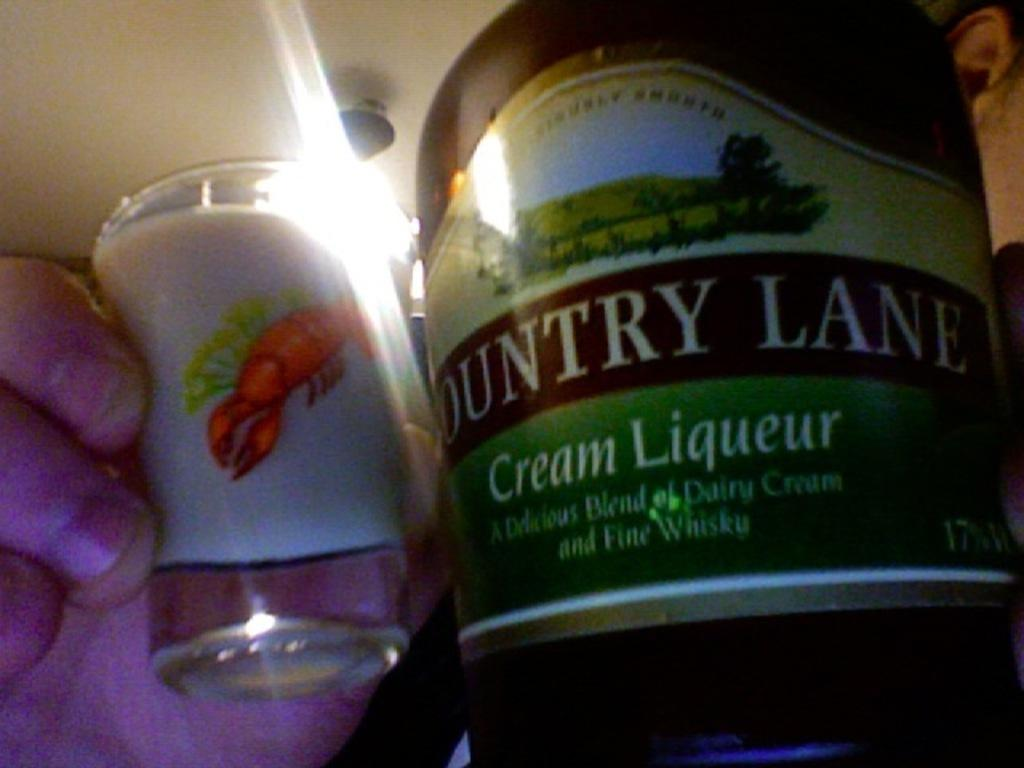<image>
Give a short and clear explanation of the subsequent image. The liqueur is from the brand Country Lane. 